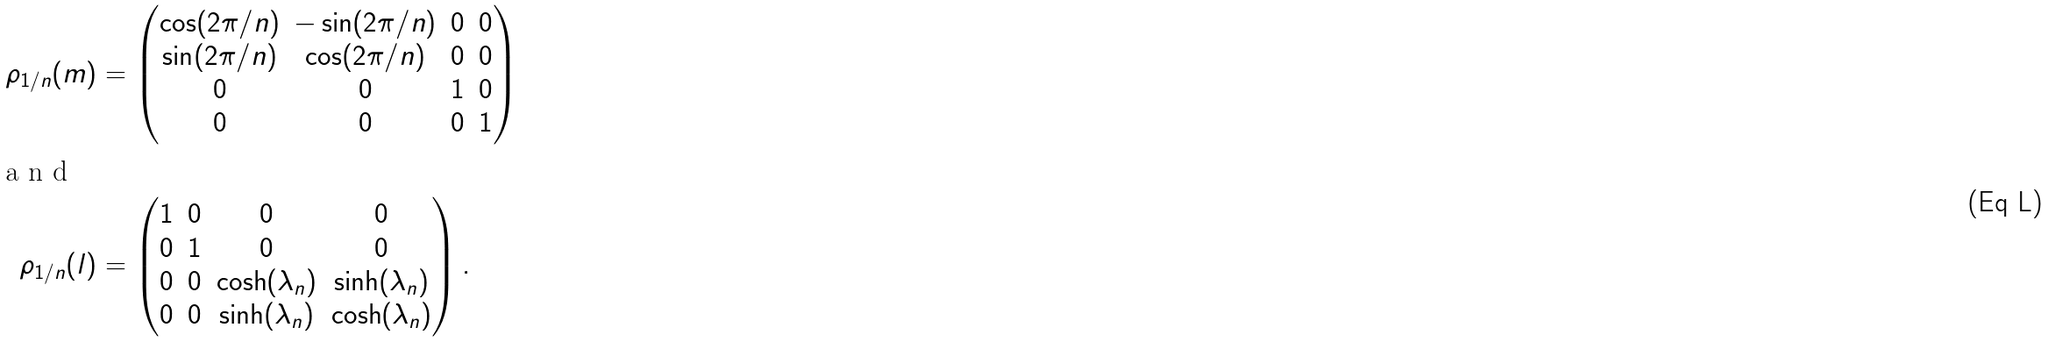Convert formula to latex. <formula><loc_0><loc_0><loc_500><loc_500>\rho _ { 1 / n } ( m ) & = \begin{pmatrix} \cos ( 2 \pi / n ) & - \sin ( 2 \pi / n ) & 0 & 0 \\ \sin ( 2 \pi / n ) & \cos ( 2 \pi / n ) & 0 & 0 \\ 0 & 0 & 1 & 0 \\ 0 & 0 & 0 & 1 \end{pmatrix} \intertext { a n d } \rho _ { 1 / n } ( l ) & = \begin{pmatrix} 1 & 0 & 0 & 0 \\ 0 & 1 & 0 & 0 \\ 0 & 0 & \cosh ( \lambda _ { n } ) & \sinh ( \lambda _ { n } ) \\ 0 & 0 & \sinh ( \lambda _ { n } ) & \cosh ( \lambda _ { n } ) \\ \end{pmatrix} .</formula> 